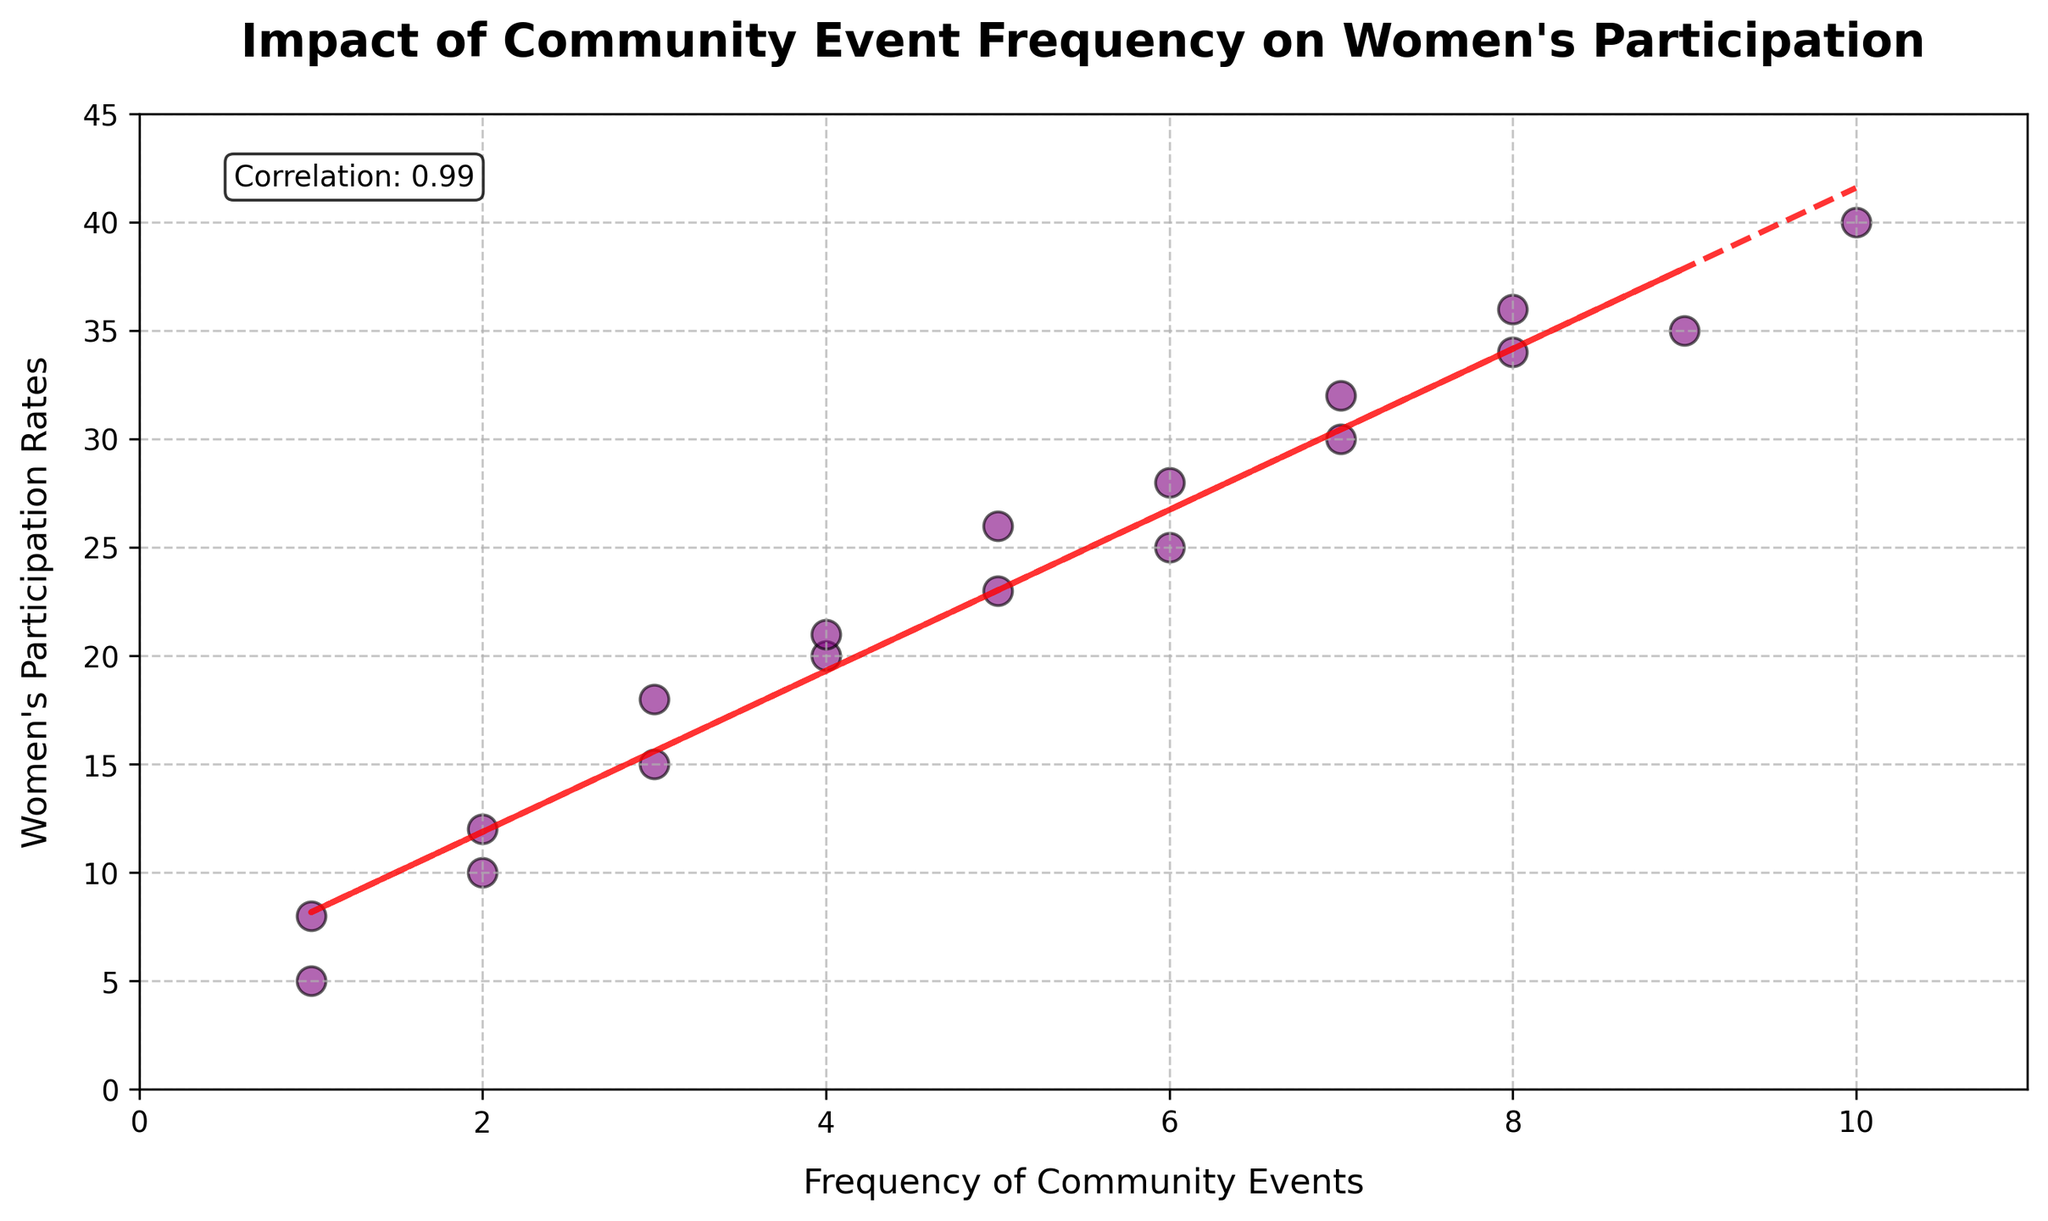What is the title of the plot? The title is displayed prominently at the top of the plot. It provides a summary of what the plot represents.
Answer: Impact of Community Event Frequency on Women's Participation How many total data points are displayed in the scatter plot? To determine the number of data points, count the individual markers (dots) in the scatter plot.
Answer: 18 What colors are used for the scatter points and the trend line? The scatter points are in purple with black edges, and the trend line is red with a dashed pattern.
Answer: Purple (points), Red Dashed (trend line) What is the correlation coefficient between Event Frequency and Participation Rates? The correlation coefficient is displayed in a text box on the top left of the plot. It quantifies the linear relationship between the two variables.
Answer: Approximately 0.98 What does the trend line in the scatter plot indicate about the relationship between Event Frequency and Women's Participation Rates? The trend line, typically fitted using linear regression, shows the general direction of the relationship. A positively sloped line indicates a positive correlation, meaning as Event Frequency increases, Women's Participation Rates also increase.
Answer: Positive relationship Between which two event frequencies is there the greatest increase in Participation Rates? To find this, look at the scatter points and note the Participation Rates for each event frequency, then identify the pair with the largest increase when moving from a lower to higher frequency.
Answer: From 1 to 3 (increase from 5 to 15) What are the participation rates when the event frequencies are 2 and 5? Locate the points on the scatter plot corresponding to the event frequencies of 2 and 5, and then note the participation rates.
Answer: 10 and 23 From the data points, does having more frequent community events consistently lead to higher participation rates? Observe the general pattern of the points and the trend line. If the majority of data points show an increasing pattern from left to right, higher frequency generally leads to higher participation rates.
Answer: Yes Is there any event frequency with a participation rate lower than 10? Scan the y-axis values for points below 10 and check their corresponding x-axis values for event frequency.
Answer: Yes, at event frequency 1 What is the range of Participation Rates shown in the plot? The range is calculated by subtracting the minimum value from the maximum value of Participation Rates displayed on the y-axis.
Answer: 5 to 40 